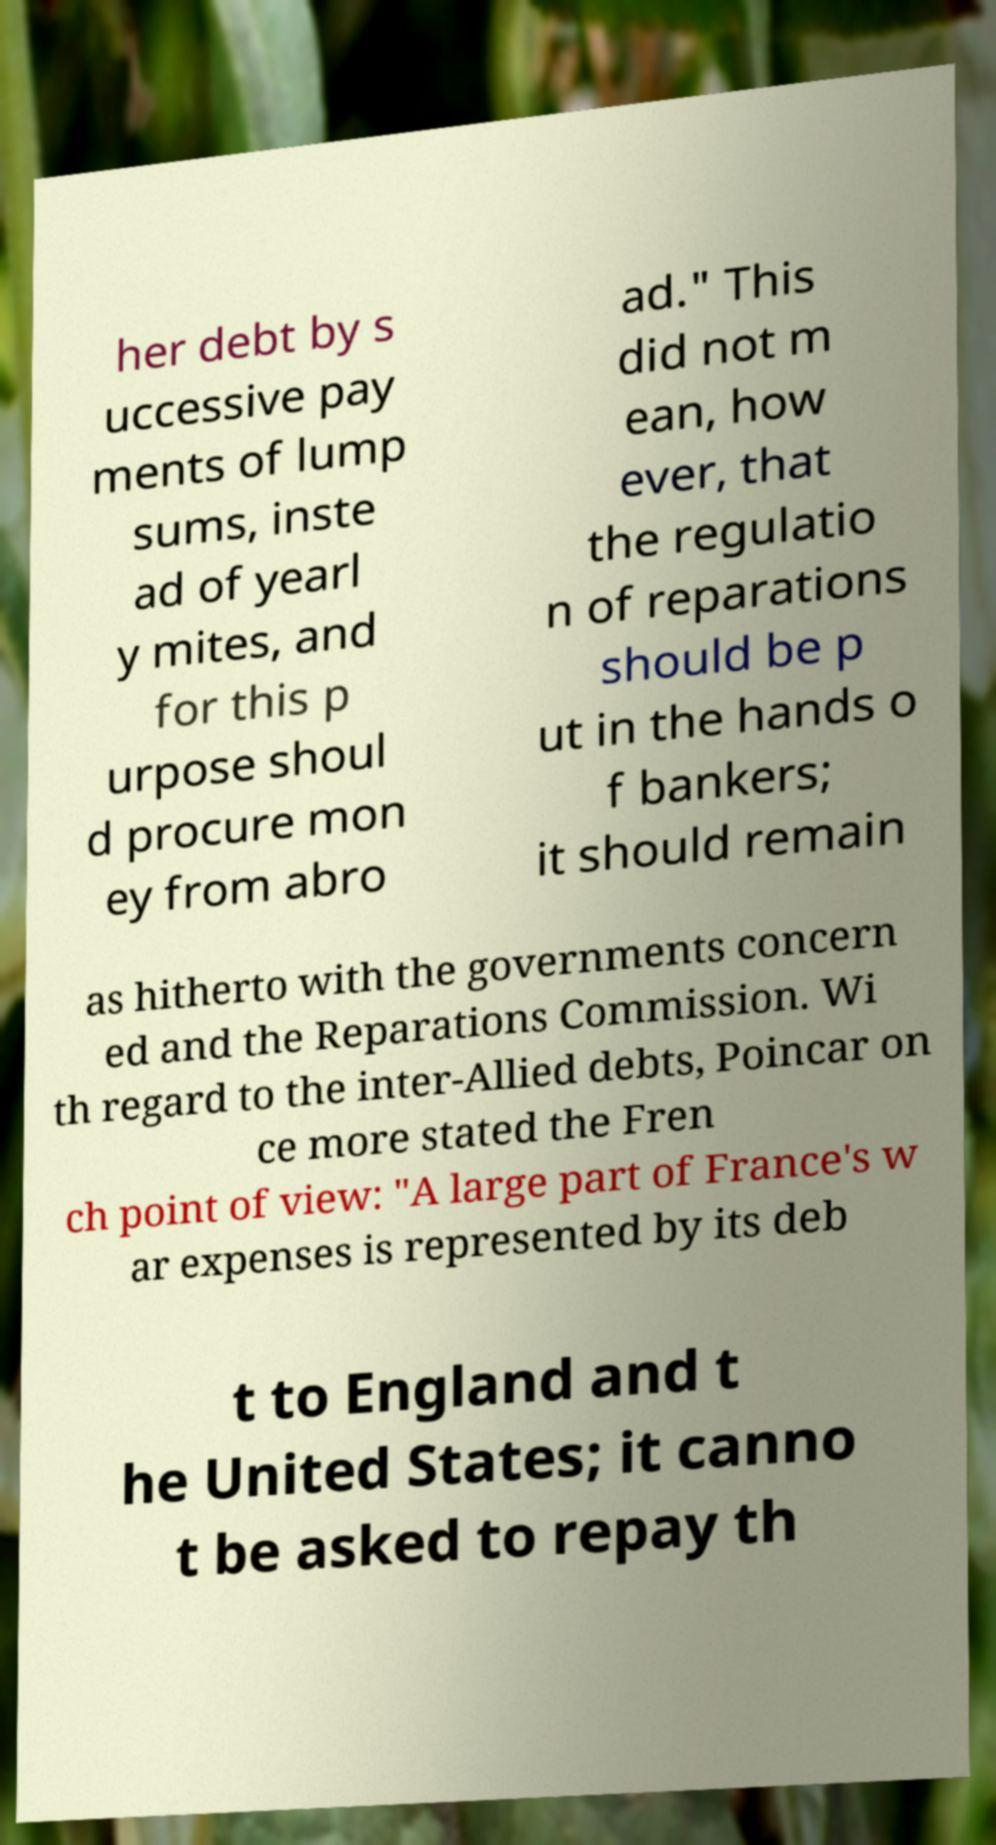What messages or text are displayed in this image? I need them in a readable, typed format. her debt by s uccessive pay ments of lump sums, inste ad of yearl y mites, and for this p urpose shoul d procure mon ey from abro ad." This did not m ean, how ever, that the regulatio n of reparations should be p ut in the hands o f bankers; it should remain as hitherto with the governments concern ed and the Reparations Commission. Wi th regard to the inter-Allied debts, Poincar on ce more stated the Fren ch point of view: "A large part of France's w ar expenses is represented by its deb t to England and t he United States; it canno t be asked to repay th 